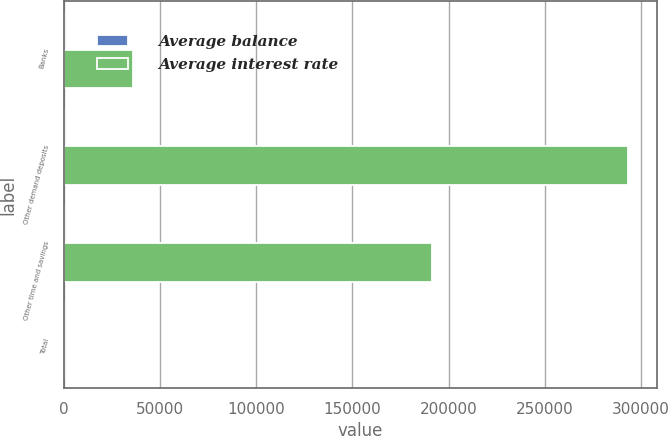<chart> <loc_0><loc_0><loc_500><loc_500><stacked_bar_chart><ecel><fcel>Banks<fcel>Other demand deposits<fcel>Other time and savings<fcel>Total<nl><fcel>Average balance<fcel>0.49<fcel>0.52<fcel>1.23<fcel>0.78<nl><fcel>Average interest rate<fcel>36063<fcel>293389<fcel>191363<fcel>1.23<nl></chart> 